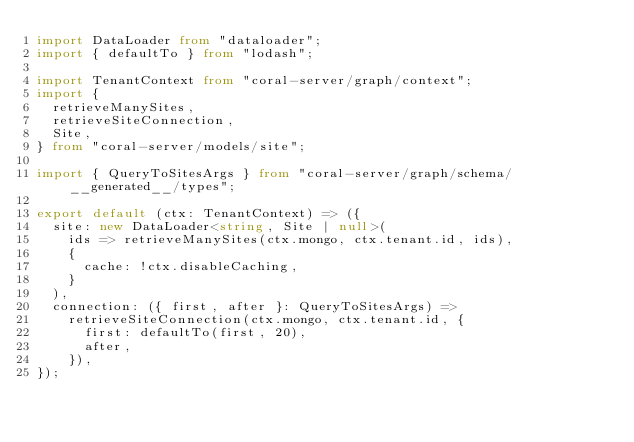<code> <loc_0><loc_0><loc_500><loc_500><_TypeScript_>import DataLoader from "dataloader";
import { defaultTo } from "lodash";

import TenantContext from "coral-server/graph/context";
import {
  retrieveManySites,
  retrieveSiteConnection,
  Site,
} from "coral-server/models/site";

import { QueryToSitesArgs } from "coral-server/graph/schema/__generated__/types";

export default (ctx: TenantContext) => ({
  site: new DataLoader<string, Site | null>(
    ids => retrieveManySites(ctx.mongo, ctx.tenant.id, ids),
    {
      cache: !ctx.disableCaching,
    }
  ),
  connection: ({ first, after }: QueryToSitesArgs) =>
    retrieveSiteConnection(ctx.mongo, ctx.tenant.id, {
      first: defaultTo(first, 20),
      after,
    }),
});
</code> 